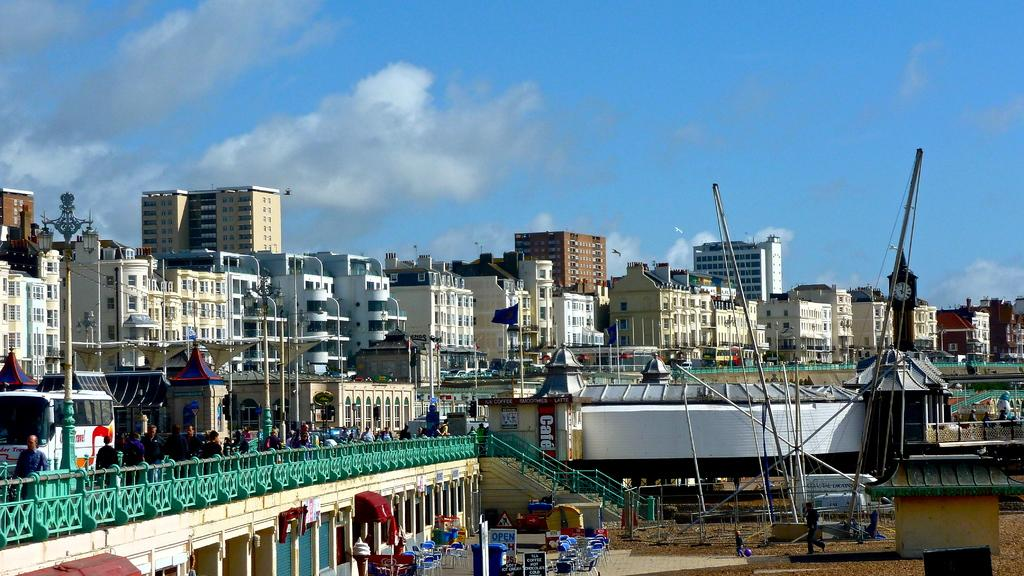What type of structures can be seen in the image? There are buildings in the image. What is happening on the road in the image? There are vehicles on the road in the image. Where are people located in the image? People can be seen on a bridge in the image. What architectural feature is present in the image? There are stairs in the image. What type of furniture is visible in the image? Tables and chairs are present in the image. What are the poles used for in the image? The purpose of the poles in the image is not specified, but they could be used for various purposes such as lighting or signage. What can be seen in the sky in the image? There are clouds in the sky in the image. What type of wood is used to construct the channel in the image? There is no channel present in the image, and therefore no wood construction can be observed. What direction are the people walking in the image? The image does not show people walking; it shows people on a bridge. 